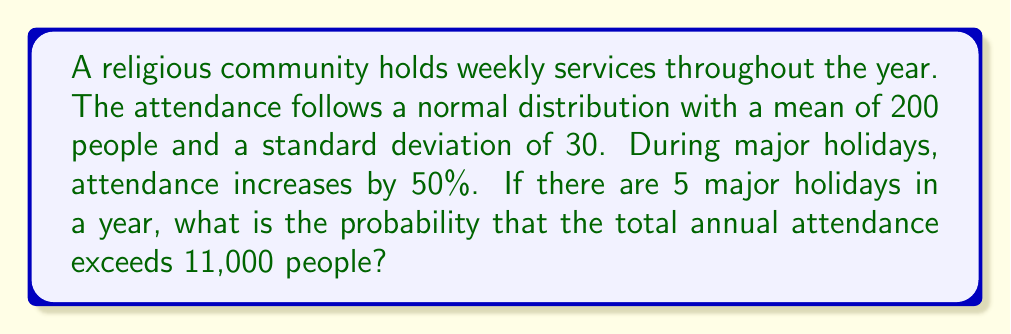Provide a solution to this math problem. Let's approach this step-by-step:

1) First, let's calculate the number of regular services:
   52 weeks - 5 holidays = 47 regular services

2) For regular services:
   Mean attendance = 200
   Standard deviation = 30

3) For holiday services:
   Mean attendance = 200 * 1.5 = 300
   We'll assume the standard deviation scales proportionally: 30 * 1.5 = 45

4) Total annual attendance is the sum of 47 regular services and 5 holiday services. This is a sum of independent normal distributions.

5) Properties of normal distributions:
   If $X_i \sim N(\mu_i, \sigma_i^2)$, then $\sum X_i \sim N(\sum \mu_i, \sum \sigma_i^2)$

6) Calculate the mean of the total annual attendance:
   $\mu_{total} = (47 * 200) + (5 * 300) = 10,900$

7) Calculate the variance of the total annual attendance:
   $\sigma^2_{total} = (47 * 30^2) + (5 * 45^2) = 52,650$

8) Standard deviation of the total annual attendance:
   $\sigma_{total} = \sqrt{52,650} \approx 229.46$

9) We want to find $P(X > 11000)$ where $X \sim N(10900, 229.46^2)$

10) Standardize:
    $z = \frac{11000 - 10900}{229.46} \approx 0.436$

11) Using the standard normal distribution table or calculator:
    $P(Z > 0.436) \approx 0.3315$

Therefore, the probability that the total annual attendance exceeds 11,000 is approximately 0.3315 or 33.15%.
Answer: 0.3315 